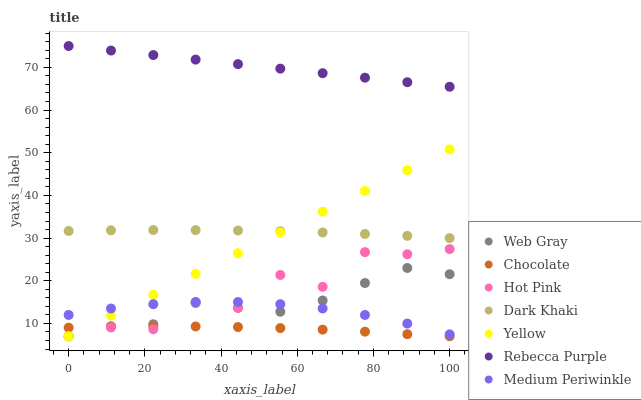Does Chocolate have the minimum area under the curve?
Answer yes or no. Yes. Does Rebecca Purple have the maximum area under the curve?
Answer yes or no. Yes. Does Hot Pink have the minimum area under the curve?
Answer yes or no. No. Does Hot Pink have the maximum area under the curve?
Answer yes or no. No. Is Yellow the smoothest?
Answer yes or no. Yes. Is Hot Pink the roughest?
Answer yes or no. Yes. Is Medium Periwinkle the smoothest?
Answer yes or no. No. Is Medium Periwinkle the roughest?
Answer yes or no. No. Does Web Gray have the lowest value?
Answer yes or no. Yes. Does Medium Periwinkle have the lowest value?
Answer yes or no. No. Does Rebecca Purple have the highest value?
Answer yes or no. Yes. Does Hot Pink have the highest value?
Answer yes or no. No. Is Yellow less than Rebecca Purple?
Answer yes or no. Yes. Is Dark Khaki greater than Web Gray?
Answer yes or no. Yes. Does Medium Periwinkle intersect Web Gray?
Answer yes or no. Yes. Is Medium Periwinkle less than Web Gray?
Answer yes or no. No. Is Medium Periwinkle greater than Web Gray?
Answer yes or no. No. Does Yellow intersect Rebecca Purple?
Answer yes or no. No. 